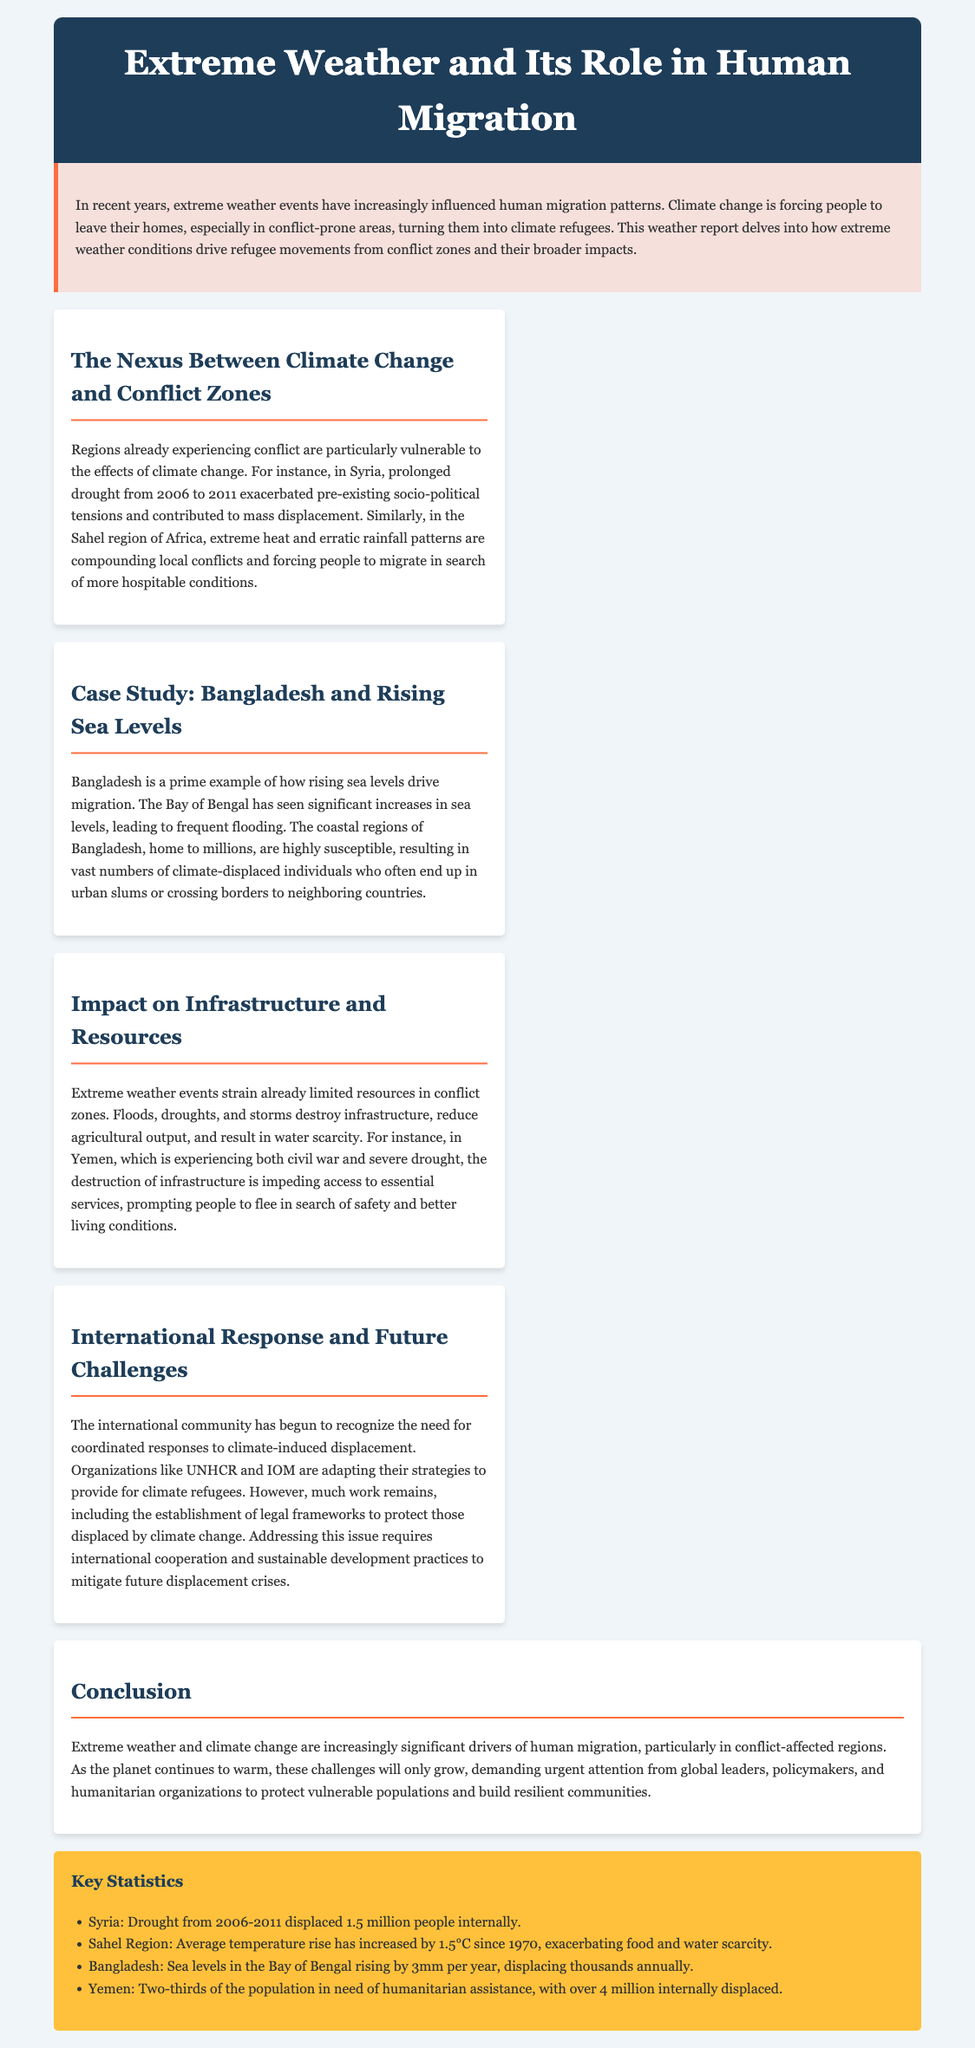What role does extreme weather play in migration? Extreme weather events have increasingly influenced human migration patterns, forcing people to leave their homes, especially in conflict-prone areas, turning them into climate refugees.
Answer: Climate refugees What is a significant result of the drought in Syria from 2006 to 2011? The prolonged drought exacerbated pre-existing socio-political tensions and contributed to mass displacement in Syria.
Answer: Mass displacement What percentage of the Yemeni population is in need of humanitarian assistance? The document states that two-thirds of the population in Yemen is in need of humanitarian assistance.
Answer: Two-thirds How much has the average temperature risen in the Sahel region since 1970? The average temperature rise in the Sahel region has increased by 1.5°C since 1970.
Answer: 1.5°C What is the rising sea level rate in the Bay of Bengal? The sea levels in the Bay of Bengal are rising at a rate of 3mm per year.
Answer: 3mm per year What do organizations like UNHCR and IOM need to establish for climate refugees? There is a need for the establishment of legal frameworks to protect those displaced by climate change.
Answer: Legal frameworks How many internally displaced people were there in Yemen? The document highlights that over 4 million individuals are internally displaced in Yemen.
Answer: Over 4 million What impact does extreme weather have on resources in conflict zones? Extreme weather events strain already limited resources, destroy infrastructure, and result in water scarcity.
Answer: Strain resources What is an urgent requirement to address displacement crises? The document states that addressing climate-induced displacement requires international cooperation and sustainable development practices.
Answer: International cooperation 